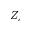Convert formula to latex. <formula><loc_0><loc_0><loc_500><loc_500>Z _ { c }</formula> 